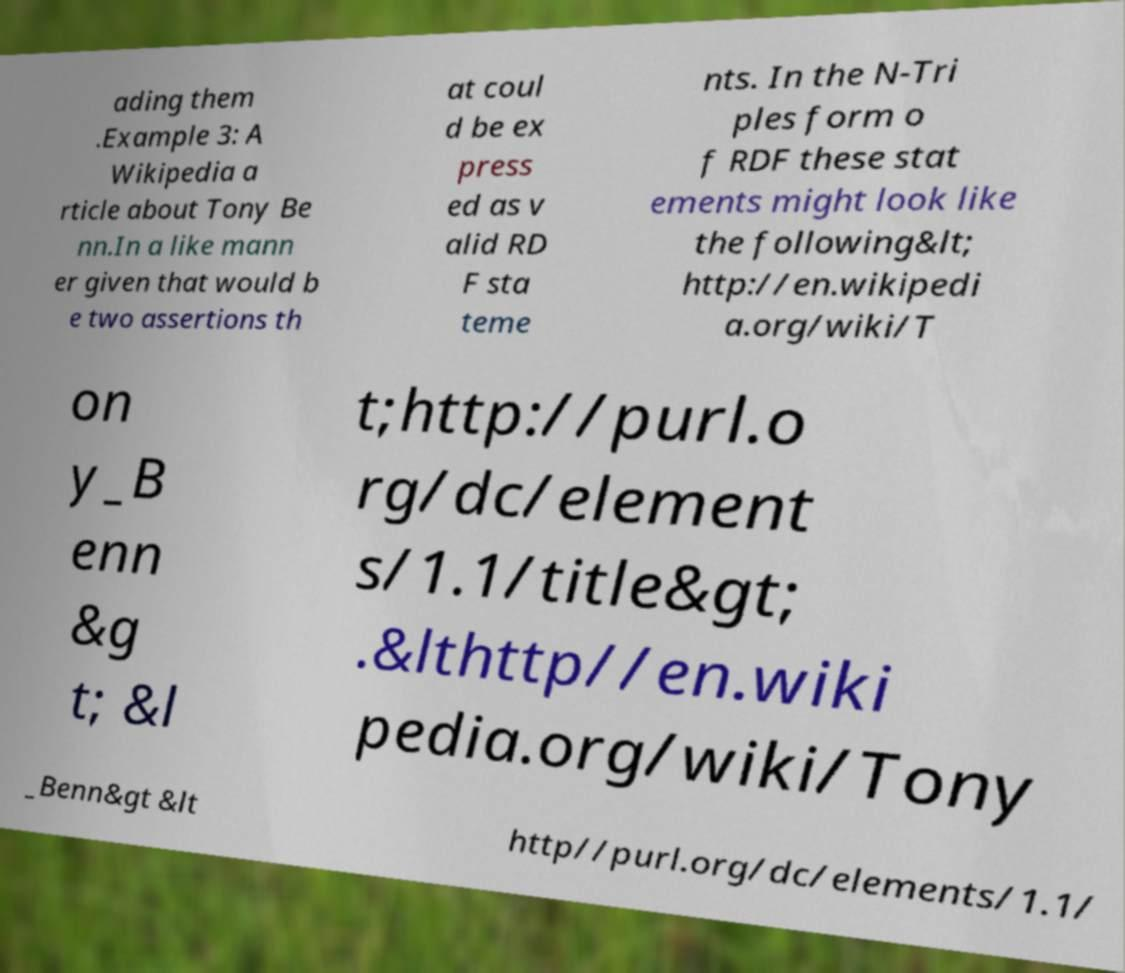Could you extract and type out the text from this image? ading them .Example 3: A Wikipedia a rticle about Tony Be nn.In a like mann er given that would b e two assertions th at coul d be ex press ed as v alid RD F sta teme nts. In the N-Tri ples form o f RDF these stat ements might look like the following&lt; http://en.wikipedi a.org/wiki/T on y_B enn &g t; &l t;http://purl.o rg/dc/element s/1.1/title&gt; .&lthttp//en.wiki pedia.org/wiki/Tony _Benn&gt &lt http//purl.org/dc/elements/1.1/ 